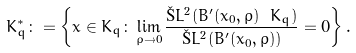Convert formula to latex. <formula><loc_0><loc_0><loc_500><loc_500>K _ { q } ^ { * } \colon = \left \{ x \in K _ { q } \colon \lim _ { \rho \to 0 } \frac { \L L ^ { 2 } ( B ^ { \prime } ( x _ { 0 } , \rho ) \ K _ { q } ) } { \L L ^ { 2 } ( B ^ { \prime } ( x _ { 0 } , \rho ) ) } = 0 \right \} .</formula> 